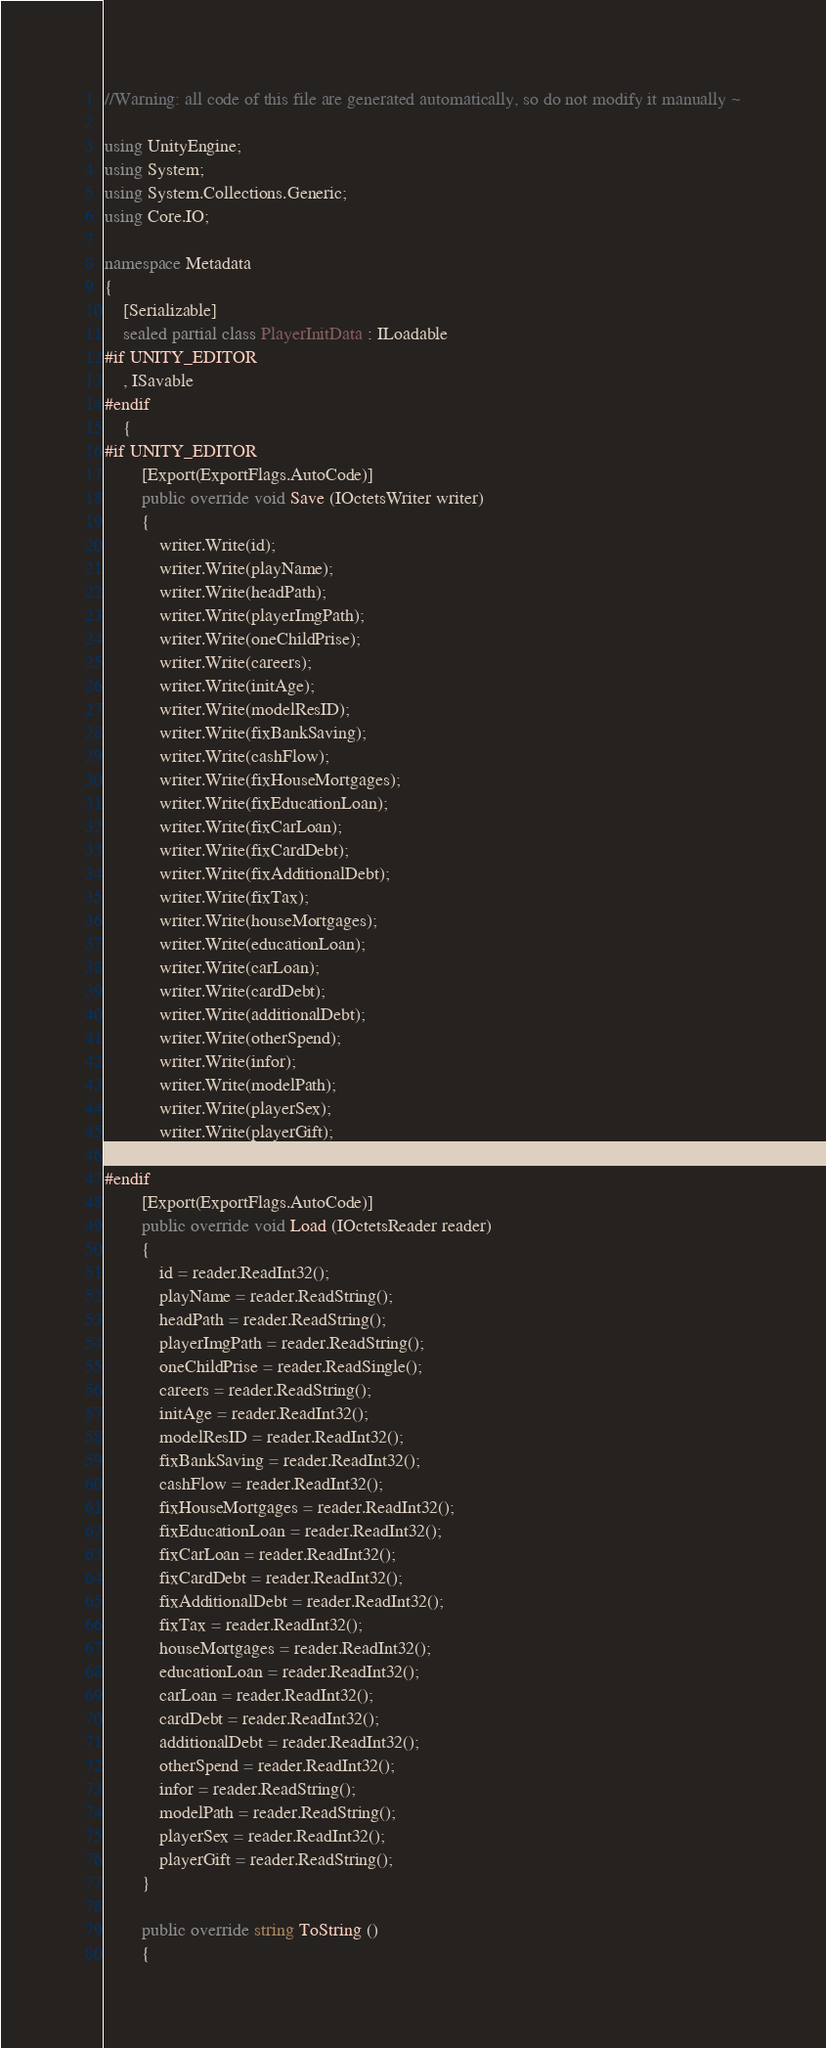<code> <loc_0><loc_0><loc_500><loc_500><_C#_>
//Warning: all code of this file are generated automatically, so do not modify it manually ~

using UnityEngine;
using System;
using System.Collections.Generic;
using Core.IO;

namespace Metadata
{
    [Serializable]
    sealed partial class PlayerInitData : ILoadable
#if UNITY_EDITOR
    , ISavable
#endif
    {
#if UNITY_EDITOR
        [Export(ExportFlags.AutoCode)]
        public override void Save (IOctetsWriter writer)
        {
            writer.Write(id);
            writer.Write(playName);
            writer.Write(headPath);
            writer.Write(playerImgPath);
            writer.Write(oneChildPrise);
            writer.Write(careers);
            writer.Write(initAge);
            writer.Write(modelResID);
            writer.Write(fixBankSaving);
            writer.Write(cashFlow);
            writer.Write(fixHouseMortgages);
            writer.Write(fixEducationLoan);
            writer.Write(fixCarLoan);
            writer.Write(fixCardDebt);
            writer.Write(fixAdditionalDebt);
            writer.Write(fixTax);
            writer.Write(houseMortgages);
            writer.Write(educationLoan);
            writer.Write(carLoan);
            writer.Write(cardDebt);
            writer.Write(additionalDebt);
            writer.Write(otherSpend);
            writer.Write(infor);
            writer.Write(modelPath);
            writer.Write(playerSex);
            writer.Write(playerGift);
        }
#endif
        [Export(ExportFlags.AutoCode)]
        public override void Load (IOctetsReader reader)
        {
            id = reader.ReadInt32();
            playName = reader.ReadString();
            headPath = reader.ReadString();
            playerImgPath = reader.ReadString();
            oneChildPrise = reader.ReadSingle();
            careers = reader.ReadString();
            initAge = reader.ReadInt32();
            modelResID = reader.ReadInt32();
            fixBankSaving = reader.ReadInt32();
            cashFlow = reader.ReadInt32();
            fixHouseMortgages = reader.ReadInt32();
            fixEducationLoan = reader.ReadInt32();
            fixCarLoan = reader.ReadInt32();
            fixCardDebt = reader.ReadInt32();
            fixAdditionalDebt = reader.ReadInt32();
            fixTax = reader.ReadInt32();
            houseMortgages = reader.ReadInt32();
            educationLoan = reader.ReadInt32();
            carLoan = reader.ReadInt32();
            cardDebt = reader.ReadInt32();
            additionalDebt = reader.ReadInt32();
            otherSpend = reader.ReadInt32();
            infor = reader.ReadString();
            modelPath = reader.ReadString();
            playerSex = reader.ReadInt32();
            playerGift = reader.ReadString();
        }

        public override string ToString ()
        {</code> 